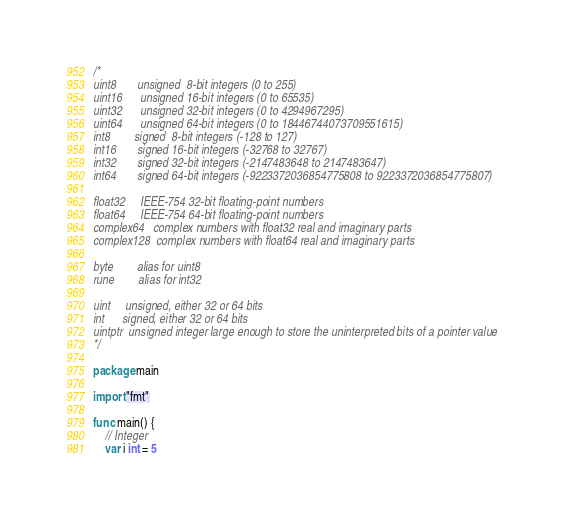Convert code to text. <code><loc_0><loc_0><loc_500><loc_500><_Go_>/*
uint8       unsigned  8-bit integers (0 to 255)
uint16      unsigned 16-bit integers (0 to 65535)
uint32      unsigned 32-bit integers (0 to 4294967295)
uint64      unsigned 64-bit integers (0 to 18446744073709551615)
int8        signed  8-bit integers (-128 to 127)
int16       signed 16-bit integers (-32768 to 32767)
int32       signed 32-bit integers (-2147483648 to 2147483647)
int64       signed 64-bit integers (-9223372036854775808 to 9223372036854775807)

float32     IEEE-754 32-bit floating-point numbers
float64     IEEE-754 64-bit floating-point numbers
complex64   complex numbers with float32 real and imaginary parts
complex128  complex numbers with float64 real and imaginary parts

byte        alias for uint8
rune        alias for int32

uint     unsigned, either 32 or 64 bits
int      signed, either 32 or 64 bits
uintptr  unsigned integer large enough to store the uninterpreted bits of a pointer value
*/

package main

import "fmt"

func main() {
	// Integer
	var i int = 5</code> 